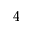Convert formula to latex. <formula><loc_0><loc_0><loc_500><loc_500>^ { 4 }</formula> 